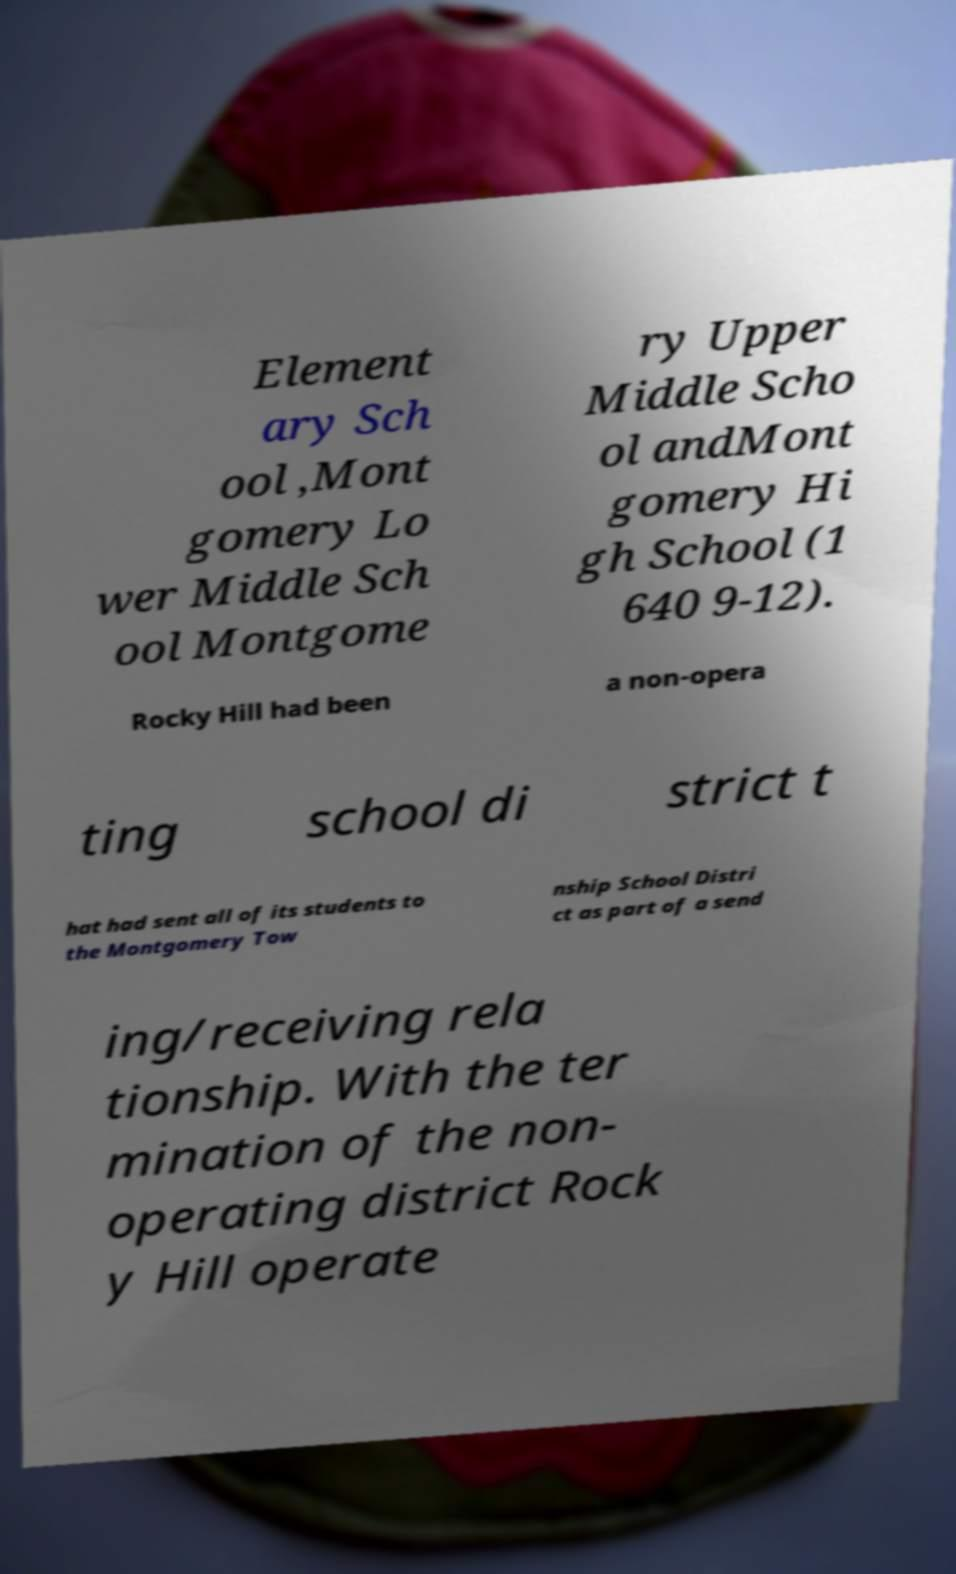What messages or text are displayed in this image? I need them in a readable, typed format. Element ary Sch ool ,Mont gomery Lo wer Middle Sch ool Montgome ry Upper Middle Scho ol andMont gomery Hi gh School (1 640 9-12). Rocky Hill had been a non-opera ting school di strict t hat had sent all of its students to the Montgomery Tow nship School Distri ct as part of a send ing/receiving rela tionship. With the ter mination of the non- operating district Rock y Hill operate 